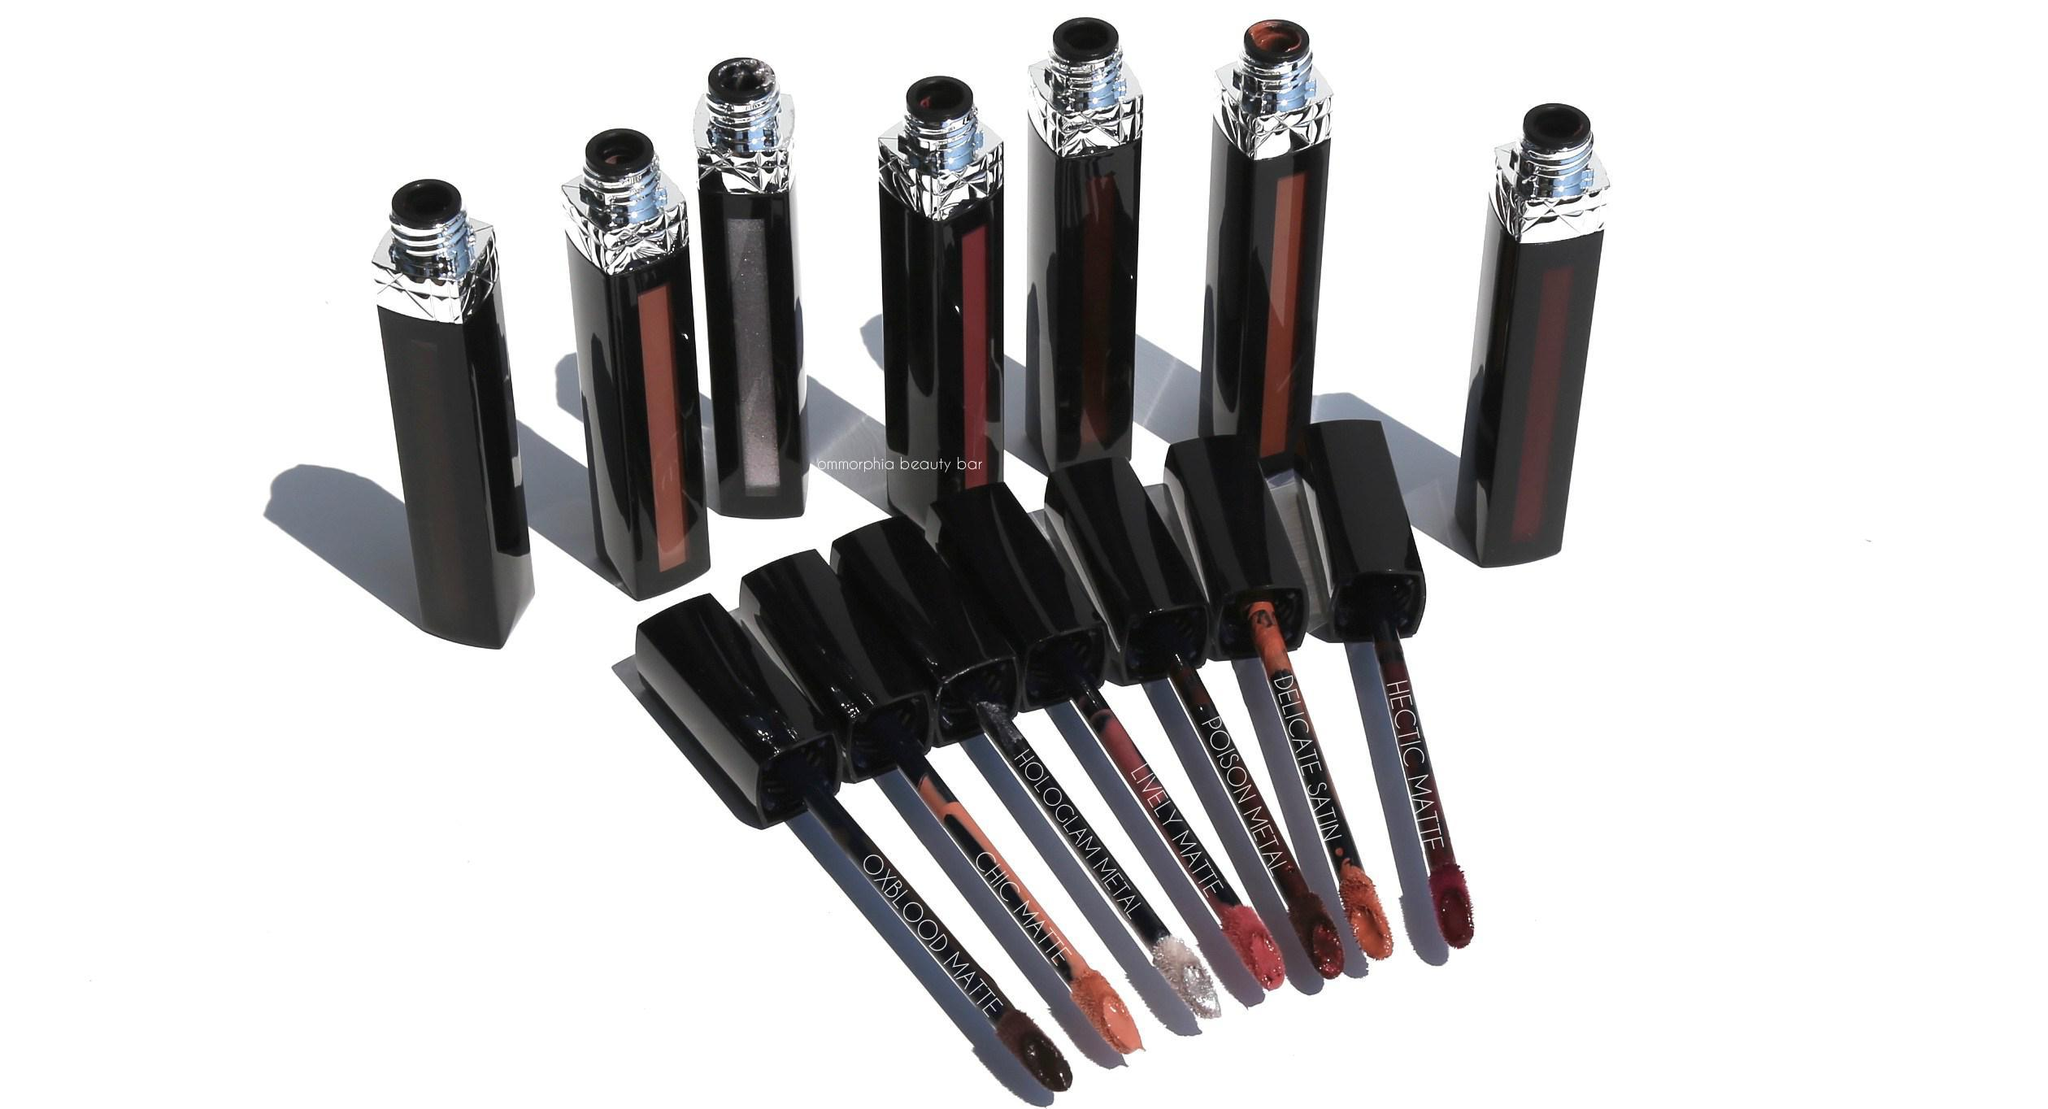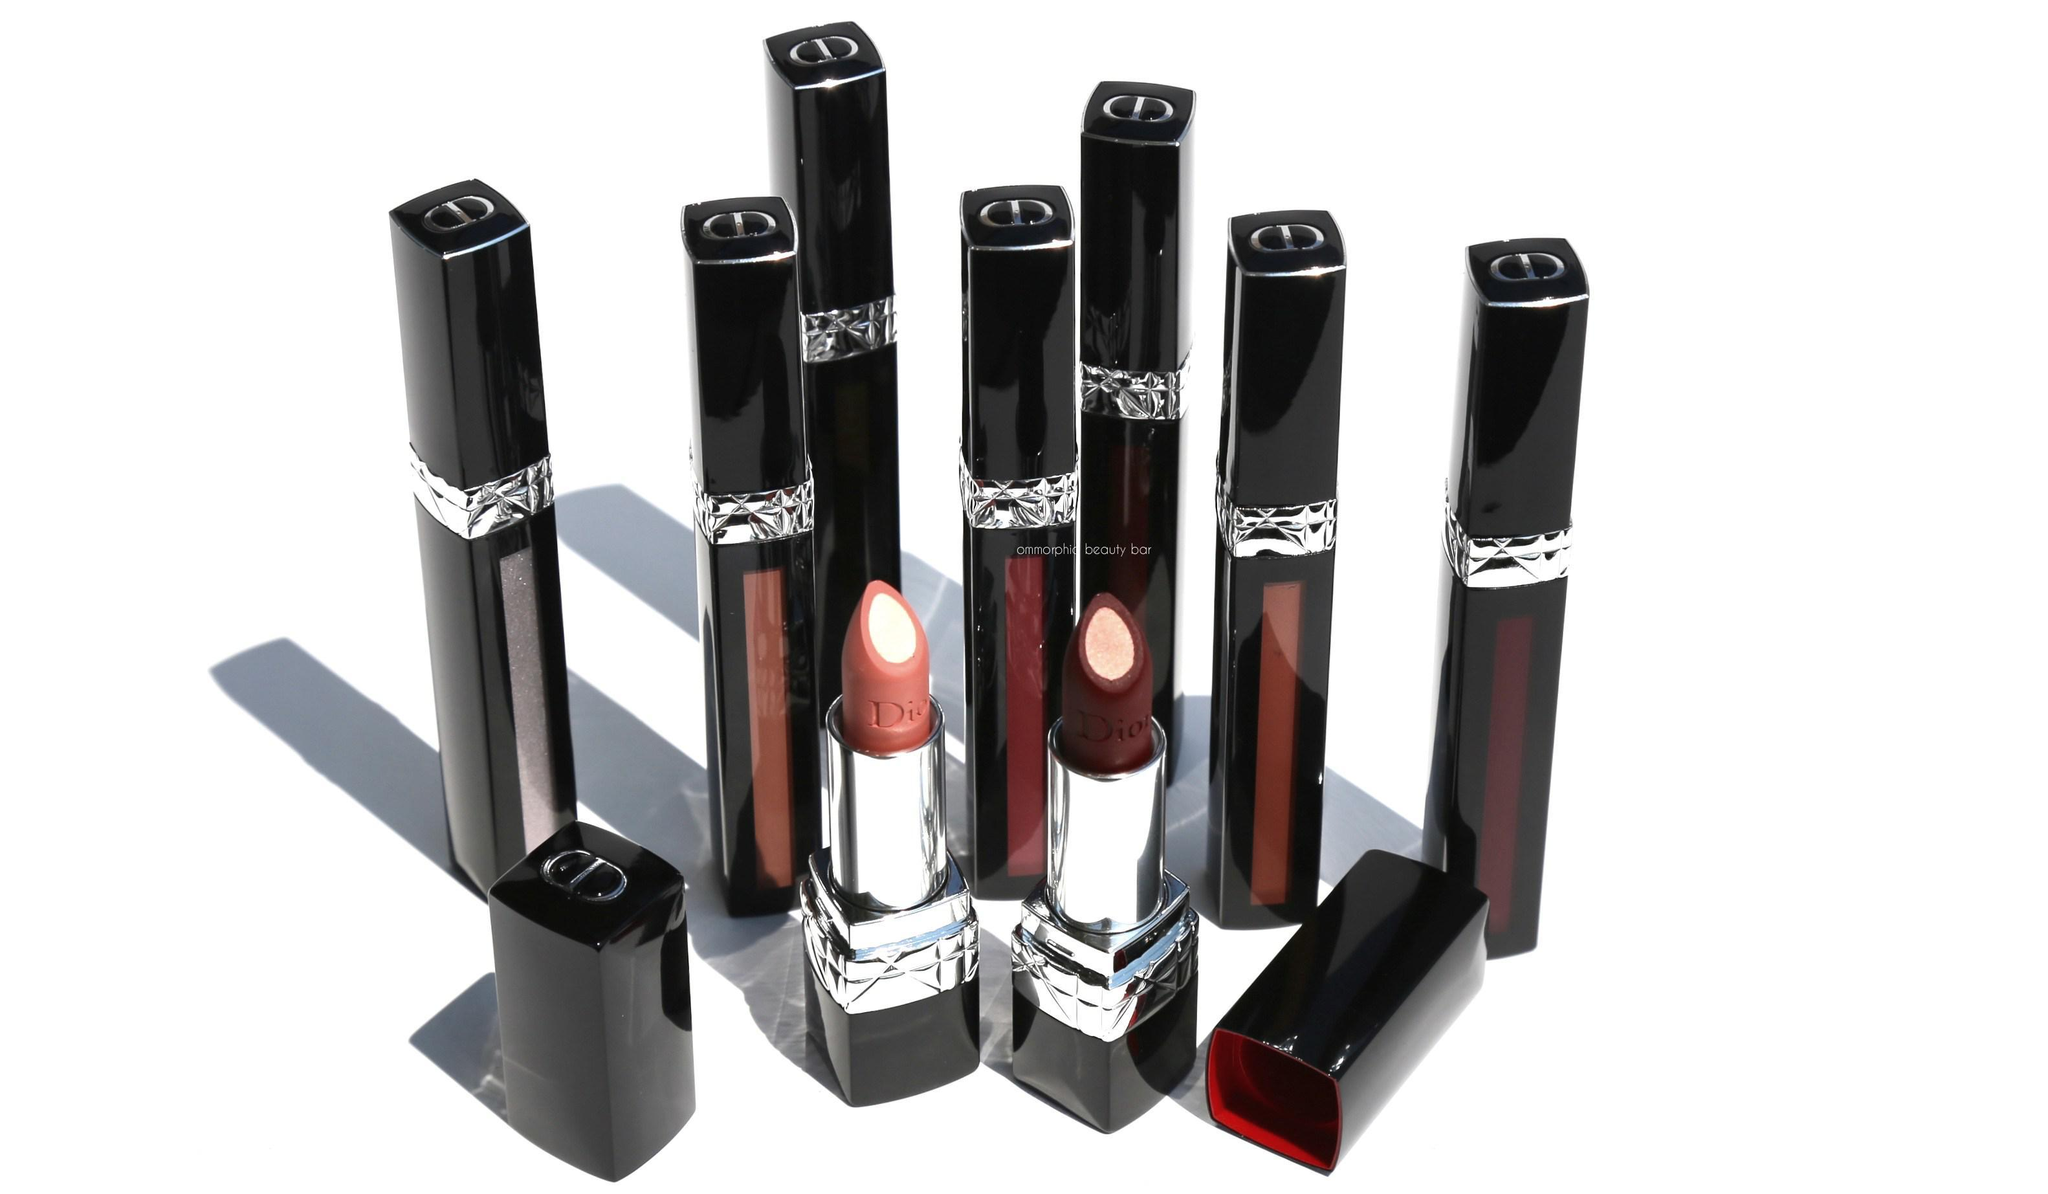The first image is the image on the left, the second image is the image on the right. Examine the images to the left and right. Is the description "In one of the images, all the items are laying on their sides." accurate? Answer yes or no. No. The first image is the image on the left, the second image is the image on the right. For the images shown, is this caption "There are at least 9 objects standing straight up in the right image." true? Answer yes or no. Yes. 